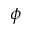Convert formula to latex. <formula><loc_0><loc_0><loc_500><loc_500>\phi</formula> 